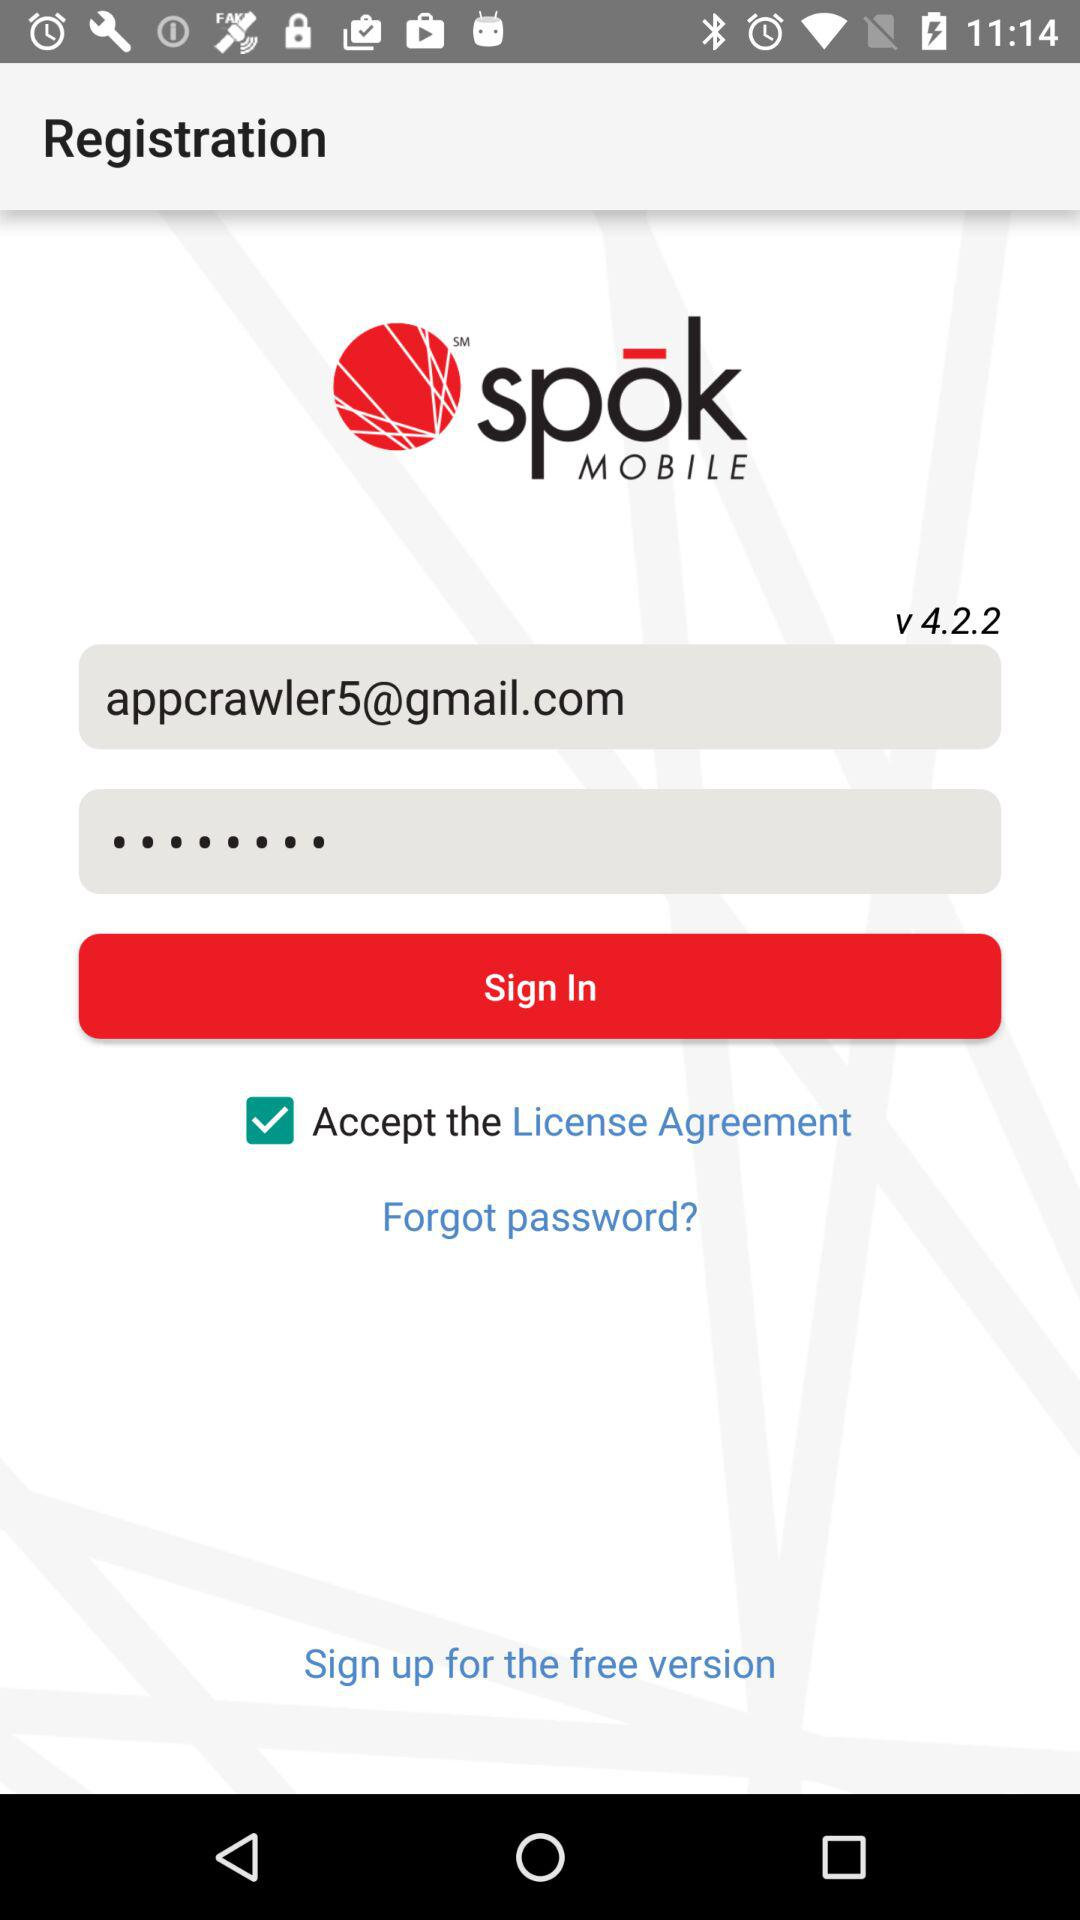What is the given email address? The given email address is appcrawler5@gmail.com. 